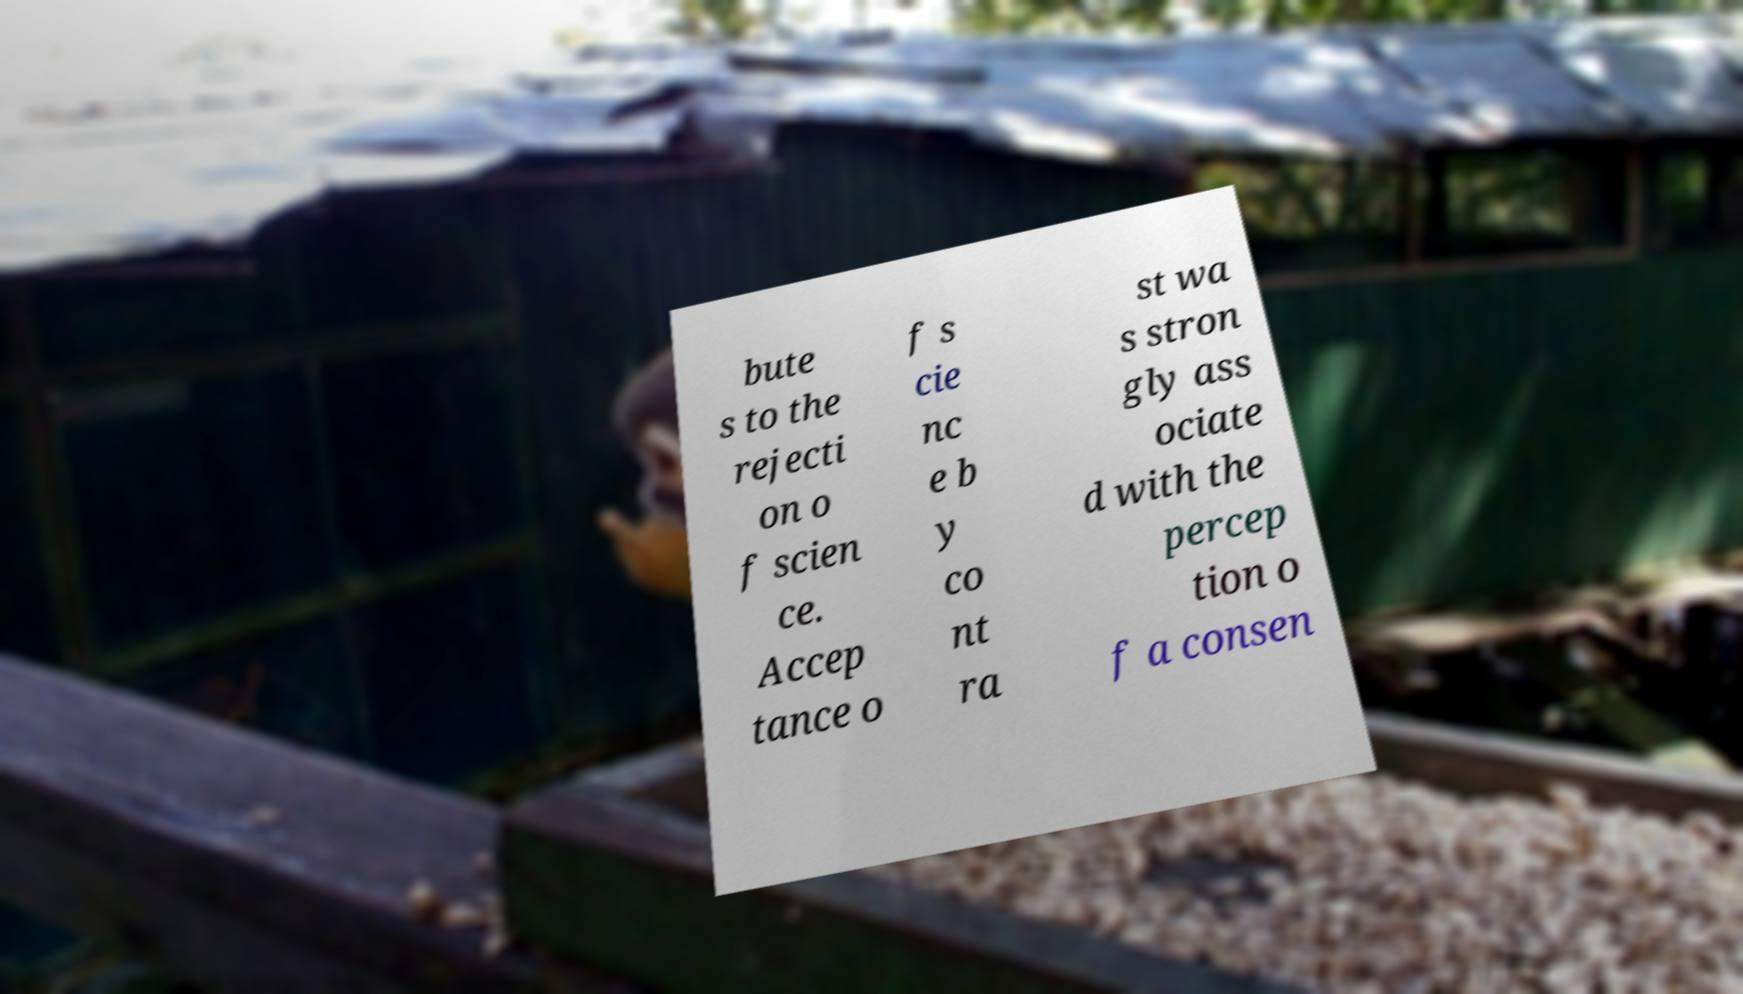I need the written content from this picture converted into text. Can you do that? bute s to the rejecti on o f scien ce. Accep tance o f s cie nc e b y co nt ra st wa s stron gly ass ociate d with the percep tion o f a consen 